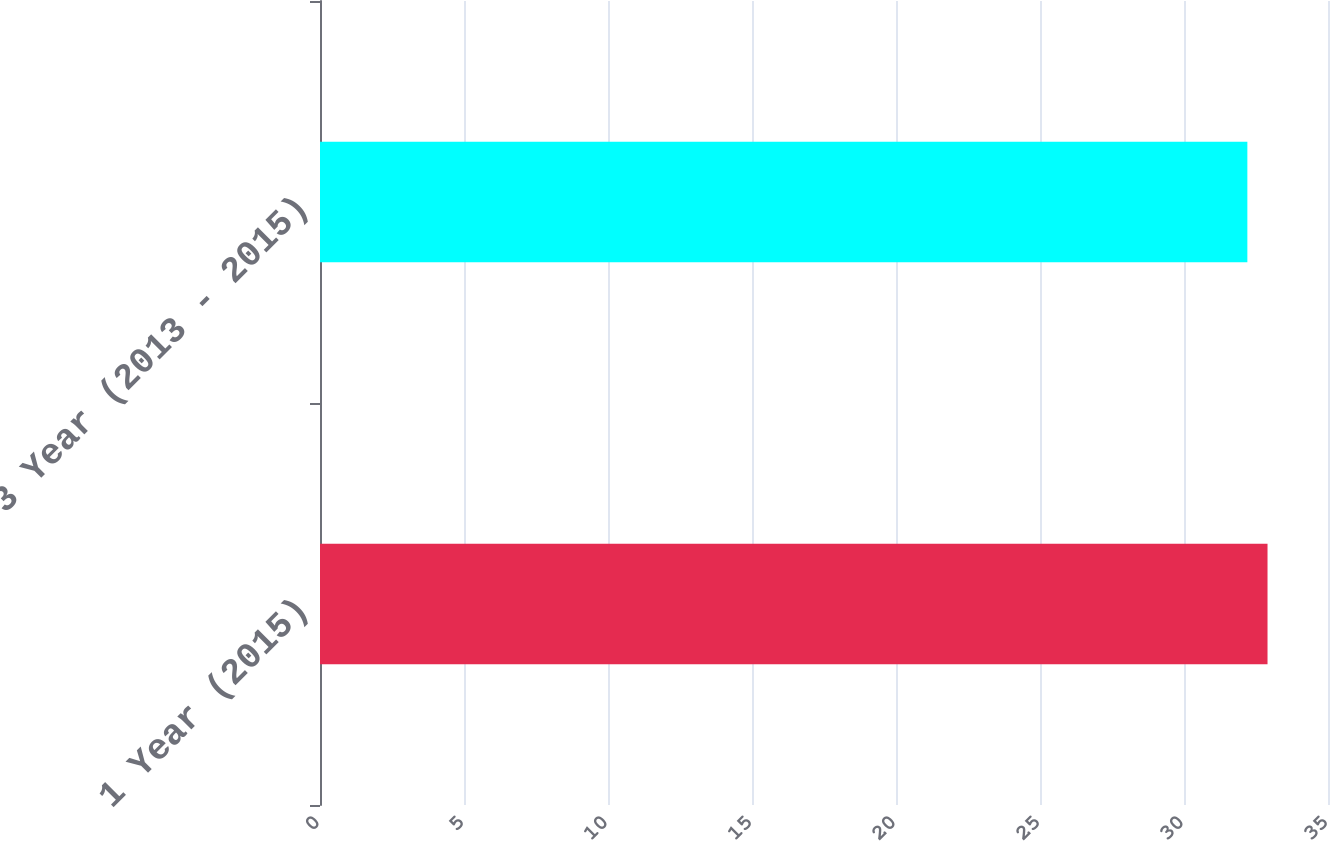Convert chart to OTSL. <chart><loc_0><loc_0><loc_500><loc_500><bar_chart><fcel>1 Year (2015)<fcel>3 Year (2013 - 2015)<nl><fcel>32.9<fcel>32.2<nl></chart> 